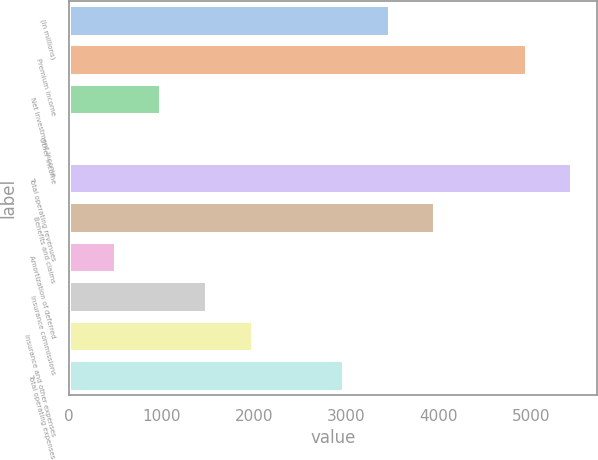<chart> <loc_0><loc_0><loc_500><loc_500><bar_chart><fcel>(In millions)<fcel>Premium income<fcel>Net investment income<fcel>Other income<fcel>Total operating revenues<fcel>Benefits and claims<fcel>Amortization of deferred<fcel>Insurance commissions<fcel>Insurance and other expenses<fcel>Total operating expenses<nl><fcel>3470.1<fcel>4953<fcel>998.6<fcel>10<fcel>5447.3<fcel>3964.4<fcel>504.3<fcel>1492.9<fcel>1987.2<fcel>2975.8<nl></chart> 